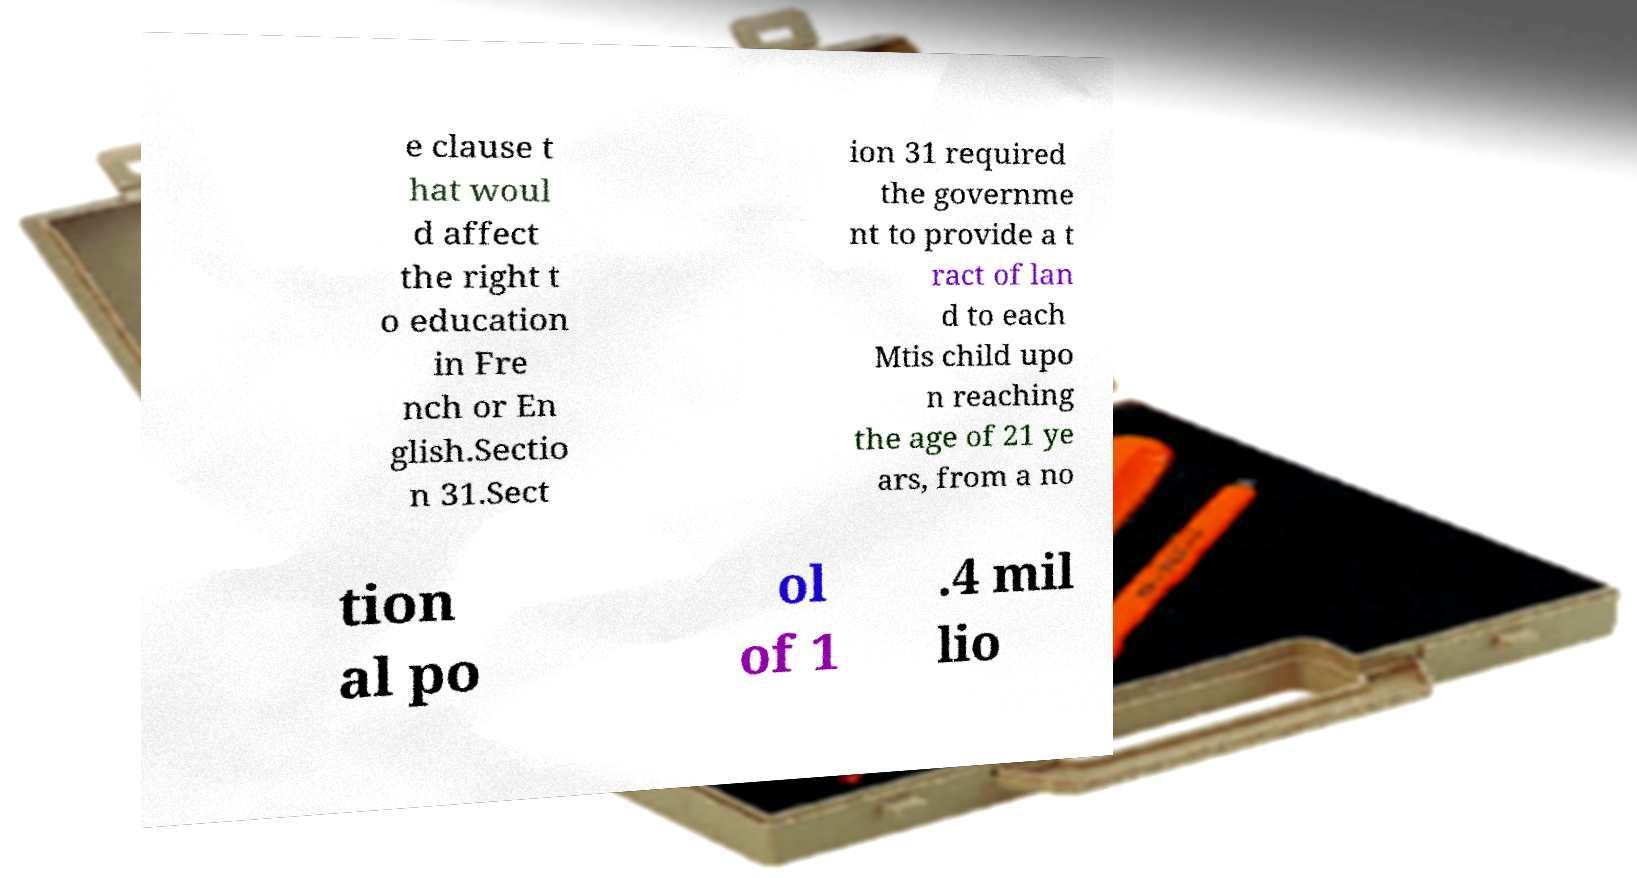Please read and relay the text visible in this image. What does it say? e clause t hat woul d affect the right t o education in Fre nch or En glish.Sectio n 31.Sect ion 31 required the governme nt to provide a t ract of lan d to each Mtis child upo n reaching the age of 21 ye ars, from a no tion al po ol of 1 .4 mil lio 